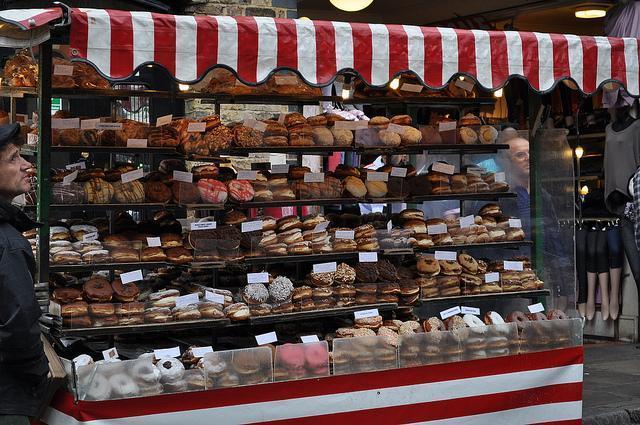How many people are in the picture?
Give a very brief answer. 2. How many donuts can you see?
Give a very brief answer. 1. 